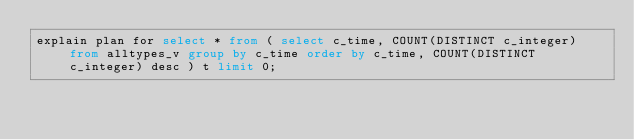<code> <loc_0><loc_0><loc_500><loc_500><_SQL_>explain plan for select * from ( select c_time, COUNT(DISTINCT c_integer) from alltypes_v group by c_time order by c_time, COUNT(DISTINCT c_integer) desc ) t limit 0;
</code> 